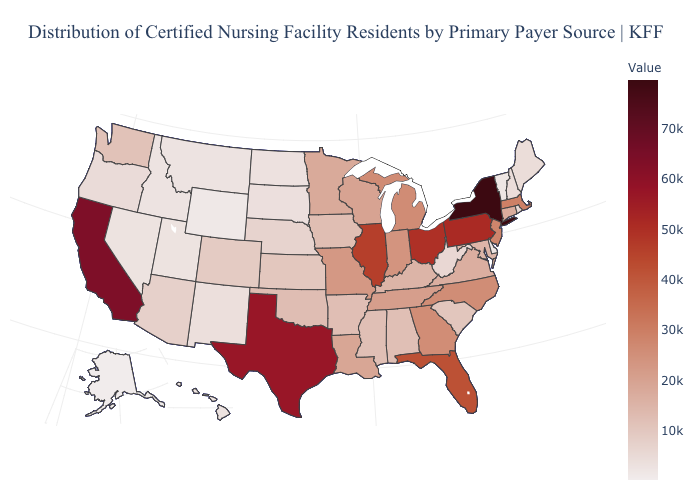Does Maryland have a higher value than South Dakota?
Keep it brief. Yes. Among the states that border Missouri , which have the highest value?
Quick response, please. Illinois. Does New Jersey have a higher value than Florida?
Be succinct. No. Does the map have missing data?
Answer briefly. No. Does the map have missing data?
Keep it brief. No. Among the states that border Michigan , does Wisconsin have the highest value?
Concise answer only. No. 